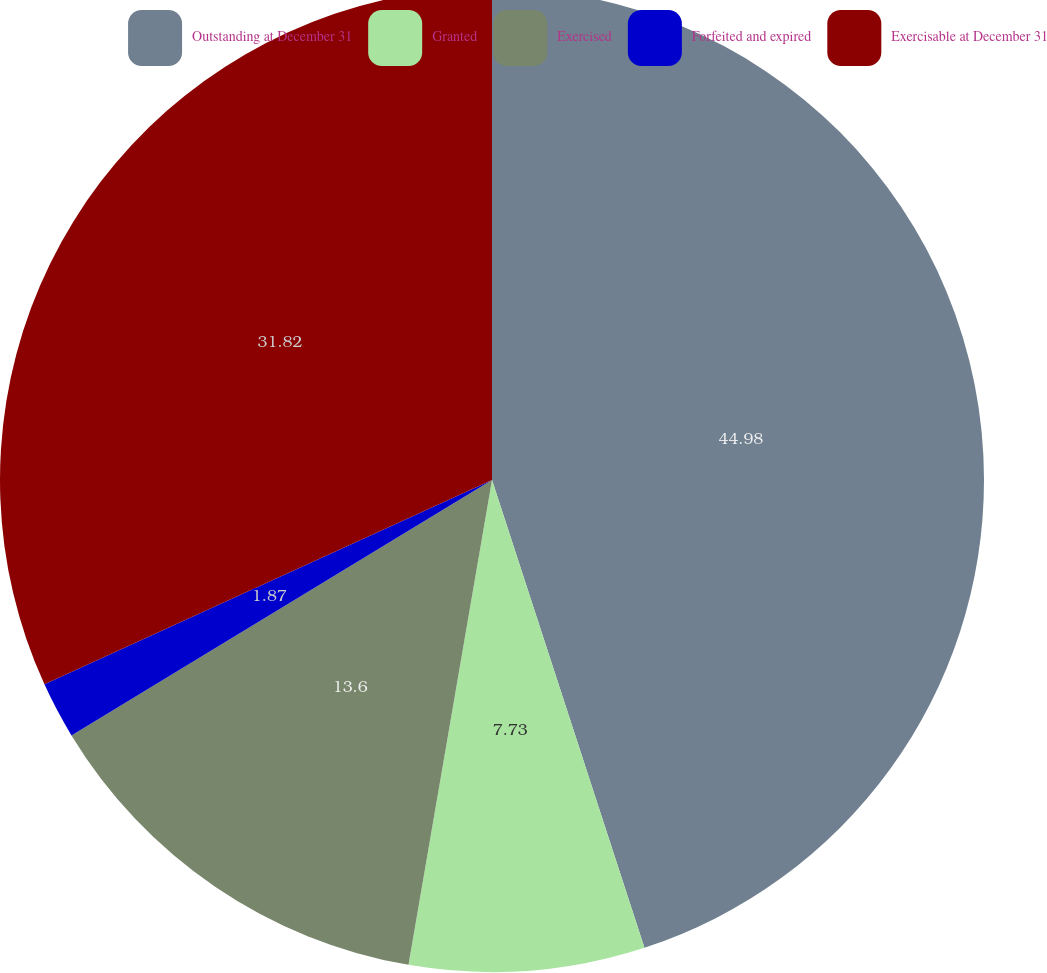Convert chart. <chart><loc_0><loc_0><loc_500><loc_500><pie_chart><fcel>Outstanding at December 31<fcel>Granted<fcel>Exercised<fcel>Forfeited and expired<fcel>Exercisable at December 31<nl><fcel>44.99%<fcel>7.73%<fcel>13.6%<fcel>1.87%<fcel>31.82%<nl></chart> 